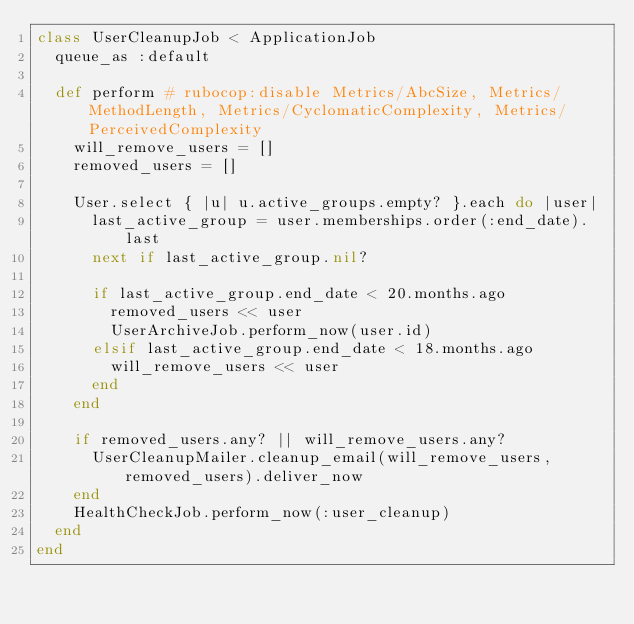Convert code to text. <code><loc_0><loc_0><loc_500><loc_500><_Ruby_>class UserCleanupJob < ApplicationJob
  queue_as :default

  def perform # rubocop:disable Metrics/AbcSize, Metrics/MethodLength, Metrics/CyclomaticComplexity, Metrics/PerceivedComplexity
    will_remove_users = []
    removed_users = []

    User.select { |u| u.active_groups.empty? }.each do |user|
      last_active_group = user.memberships.order(:end_date).last
      next if last_active_group.nil?

      if last_active_group.end_date < 20.months.ago
        removed_users << user
        UserArchiveJob.perform_now(user.id)
      elsif last_active_group.end_date < 18.months.ago
        will_remove_users << user
      end
    end

    if removed_users.any? || will_remove_users.any?
      UserCleanupMailer.cleanup_email(will_remove_users, removed_users).deliver_now
    end
    HealthCheckJob.perform_now(:user_cleanup)
  end
end
</code> 